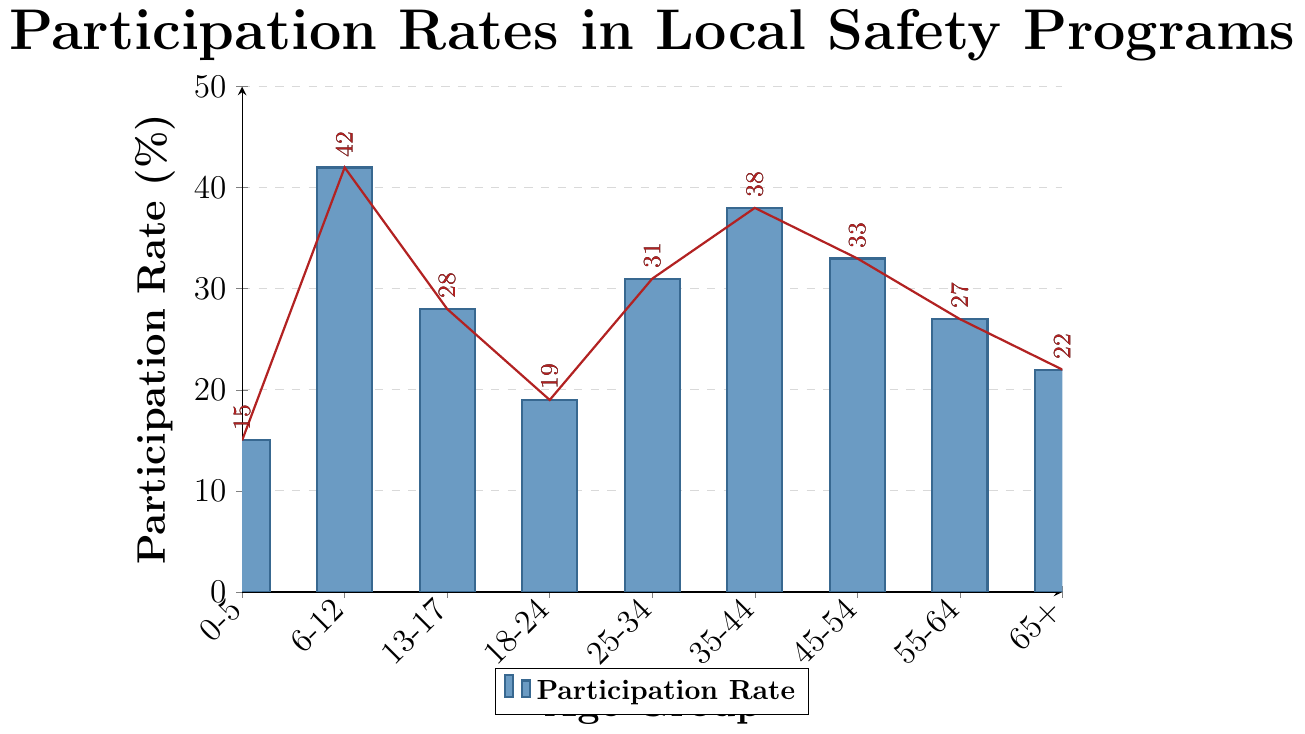What age group has the highest participation rate? The highest bar on the graph represents the age group 6-12, which visually shows the tallest bar and highest percentage.
Answer: 6-12 Which two age groups have the closest participation rates? By comparing the heights of the bars, the age groups 18-24 and 65+ have the closest participation rates, with each falling around the 19-22% range.
Answer: 18-24 and 65+ What is the difference between the highest and lowest participation rates? The highest participation rate is from the age group 6-12 (42%) and the lowest is from the age group 0-5 (15%). The difference is calculated as 42 - 15.
Answer: 27% Is the participation rate of the age group 35-44 greater than or equal to the age group 45-54? By comparing the bar heights, the age group 35-44 has a participation rate of 38% which is slightly higher than the age group 45-54 at 33%.
Answer: Yes What is the average participation rate of the age groups 13-17, 18-24, and 25-34? Sum the participation rates of these age groups: 28% + 19% + 31% = 78%. Divide by the number of age groups (3).
Answer: 26% Which age groups have a participation rate greater than 30%? By inspecting the graph, the age groups 6-12, 25-34, 35-44, and 45-54 all have bars that extend above 30%.
Answer: 6-12, 25-34, 35-44, 45-54 What is the participation rate for the age group 55-64? Locate the bar corresponding to the age group 55-64. The height of the bar indicates the participation rate is 27%.
Answer: 27% Identify the median participation rate from all age groups. Arrange the participation rates in ascending order: 15, 19, 22, 27, 28, 31, 33, 38, 42. The median is the middle value, which is 28.
Answer: 28% How much higher is the participation rate of the age group 6-12 compared to the age group 0-5? The participation rate of the age group 6-12 is 42% and for the age group 0-5 is 15%. The difference is calculated as 42 - 15.
Answer: 27% higher 